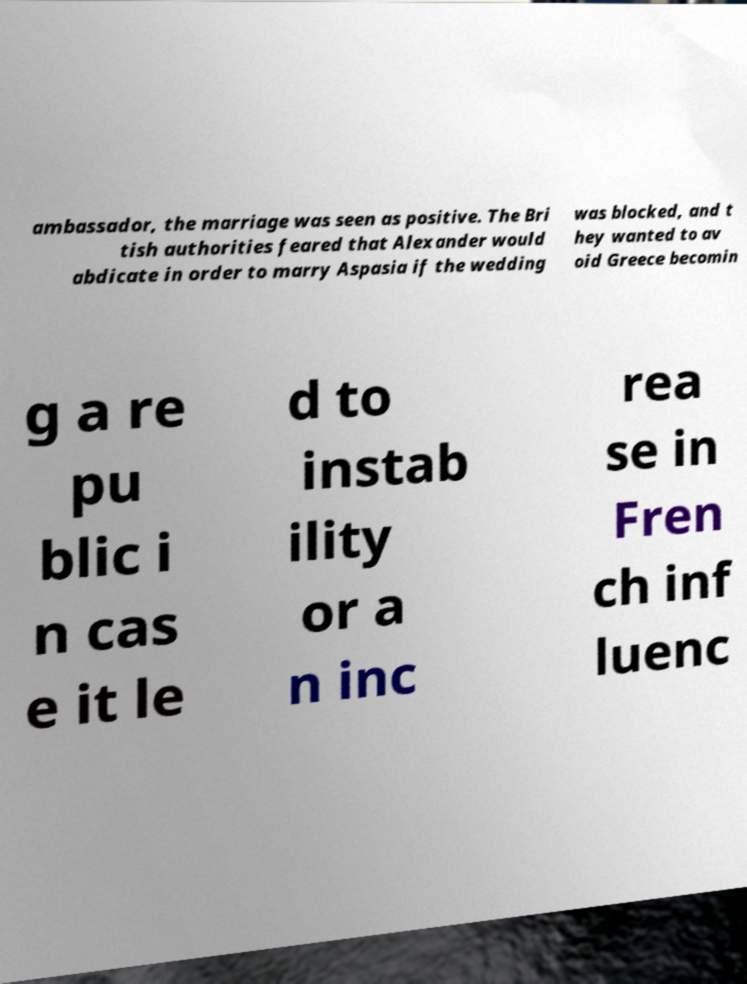Can you accurately transcribe the text from the provided image for me? ambassador, the marriage was seen as positive. The Bri tish authorities feared that Alexander would abdicate in order to marry Aspasia if the wedding was blocked, and t hey wanted to av oid Greece becomin g a re pu blic i n cas e it le d to instab ility or a n inc rea se in Fren ch inf luenc 